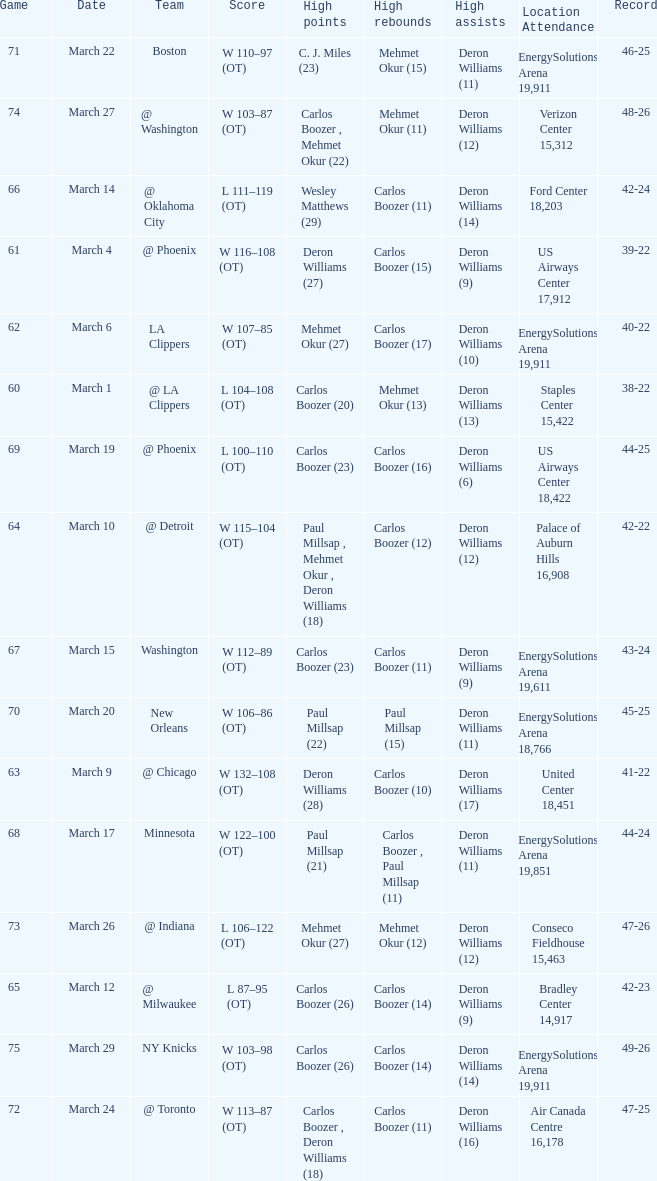How many players did the most high points in the game with 39-22 record? 1.0. 